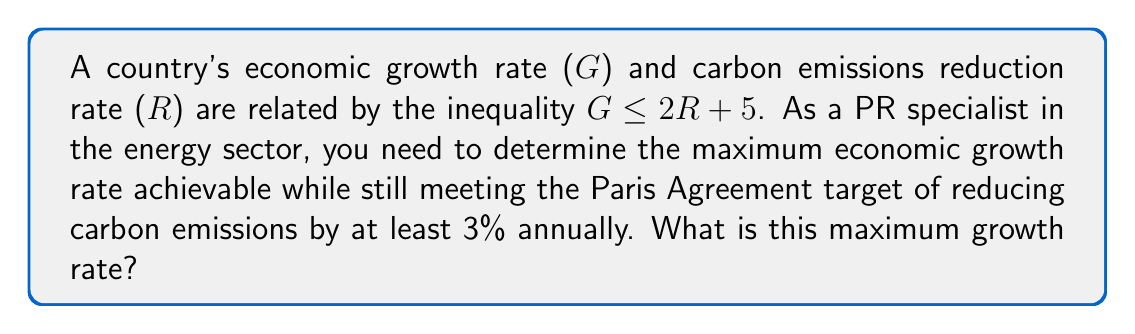Can you solve this math problem? 1) We are given the inequality: $G \leq 2R + 5$

2) The Paris Agreement target requires a minimum 3% reduction in carbon emissions annually. This means R ≥ 3.

3) To find the maximum economic growth rate (G), we need to use the maximum possible value for R in our inequality. Since R ≥ 3, the maximum value occurs when R = 3.

4) Substituting R = 3 into our original inequality:
   $G \leq 2(3) + 5$

5) Simplify:
   $G \leq 6 + 5$
   $G \leq 11$

6) Therefore, the maximum economic growth rate achievable while still meeting the Paris Agreement target is 11%.
Answer: 11% 